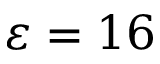<formula> <loc_0><loc_0><loc_500><loc_500>\varepsilon = 1 6</formula> 